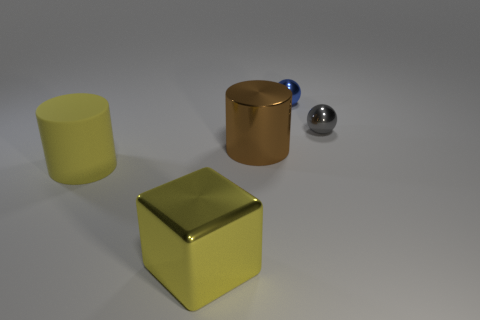Add 2 big matte blocks. How many objects exist? 7 Subtract all spheres. How many objects are left? 3 Add 1 small shiny objects. How many small shiny objects are left? 3 Add 1 small blue things. How many small blue things exist? 2 Subtract 0 red cylinders. How many objects are left? 5 Subtract all brown metallic cylinders. Subtract all small gray metallic things. How many objects are left? 3 